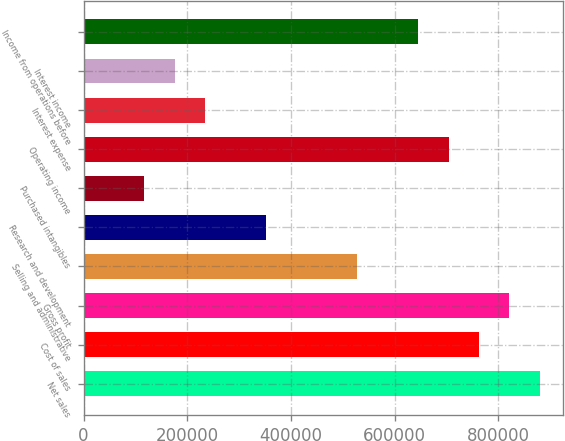Convert chart to OTSL. <chart><loc_0><loc_0><loc_500><loc_500><bar_chart><fcel>Net sales<fcel>Cost of sales<fcel>Gross profit<fcel>Selling and administrative<fcel>Research and development<fcel>Purchased intangibles<fcel>Operating income<fcel>Interest expense<fcel>Interest income<fcel>Income from operations before<nl><fcel>879914<fcel>762592<fcel>821253<fcel>527949<fcel>351967<fcel>117323<fcel>703932<fcel>234645<fcel>175984<fcel>645271<nl></chart> 